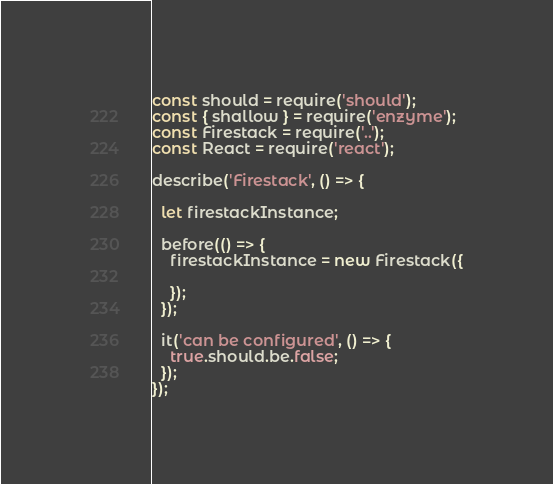Convert code to text. <code><loc_0><loc_0><loc_500><loc_500><_JavaScript_>const should = require('should');
const { shallow } = require('enzyme');
const Firestack = require('..');
const React = require('react');

describe('Firestack', () => {

  let firestackInstance;

  before(() => {
    firestackInstance = new Firestack({

    });
  });

  it('can be configured', () => {
    true.should.be.false;
  });
});</code> 